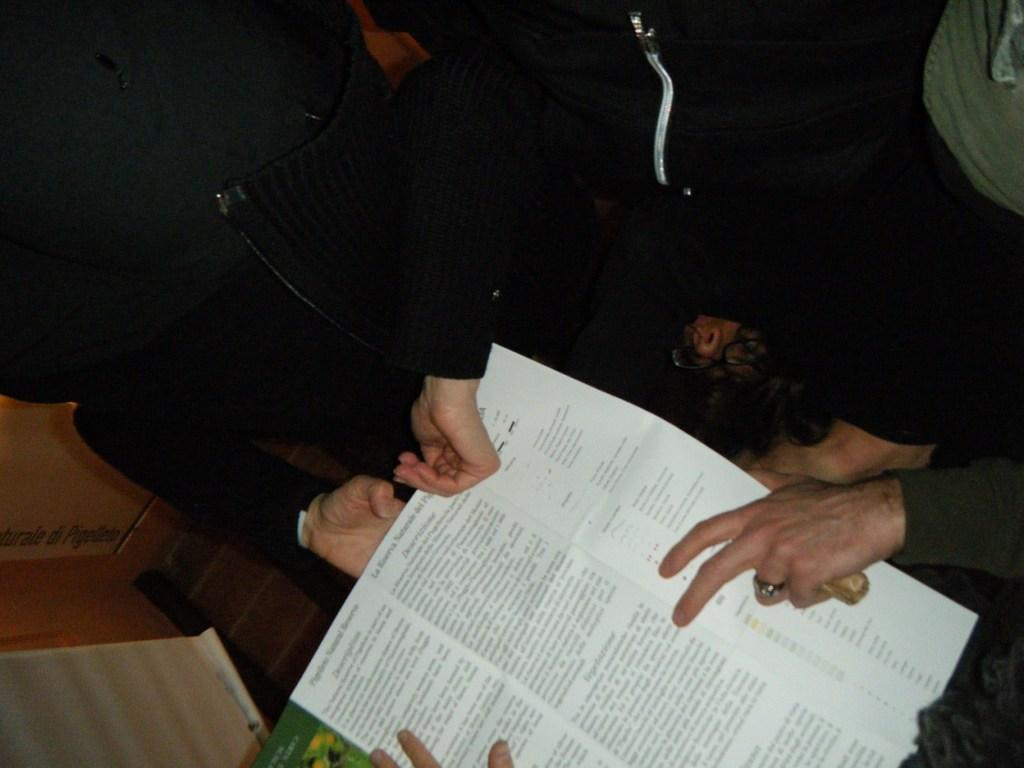Who or what is present in the image? There are people in the image. What are the people holding in the image? The people are holding a paper. What type of clothing are the people wearing in the image? The people are wearing winter clothes. What type of song can be heard playing in the background of the image? There is no information about any song or background music in the image. 